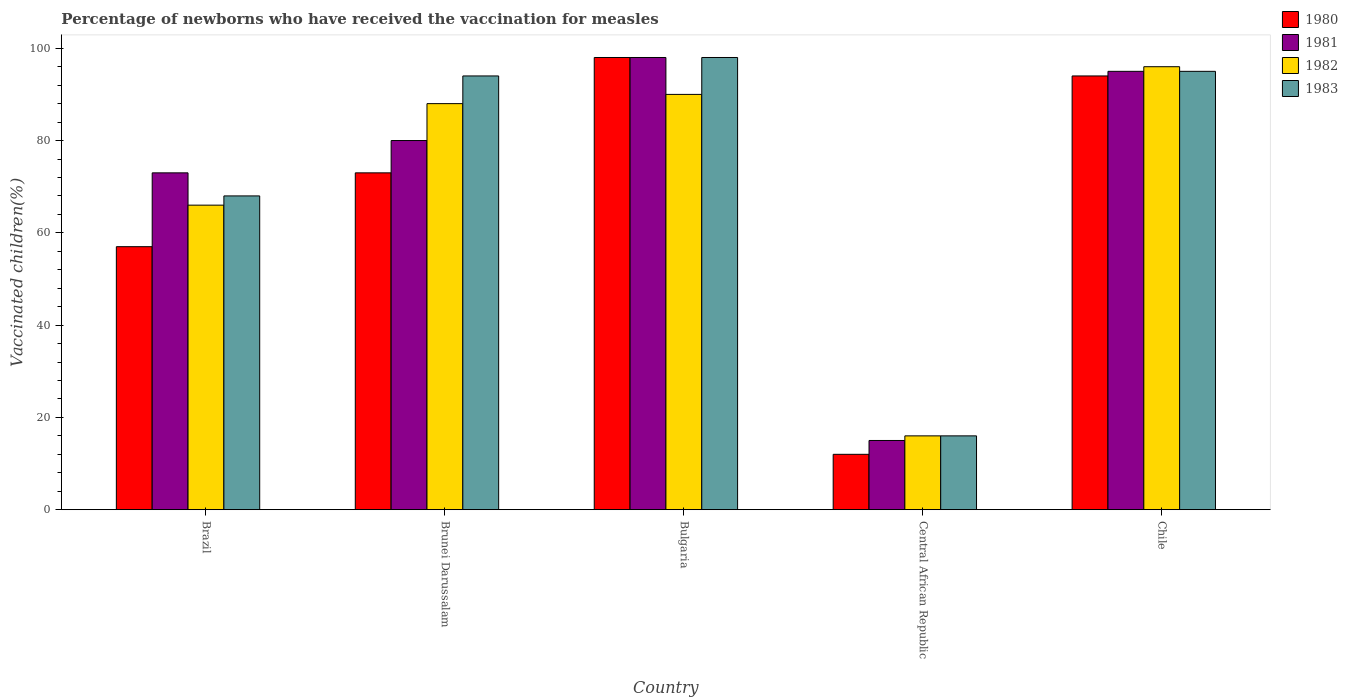How many different coloured bars are there?
Offer a very short reply. 4. Are the number of bars per tick equal to the number of legend labels?
Provide a succinct answer. Yes. Are the number of bars on each tick of the X-axis equal?
Make the answer very short. Yes. Across all countries, what is the maximum percentage of vaccinated children in 1980?
Provide a short and direct response. 98. Across all countries, what is the minimum percentage of vaccinated children in 1980?
Provide a short and direct response. 12. In which country was the percentage of vaccinated children in 1983 maximum?
Your answer should be compact. Bulgaria. In which country was the percentage of vaccinated children in 1981 minimum?
Keep it short and to the point. Central African Republic. What is the total percentage of vaccinated children in 1980 in the graph?
Make the answer very short. 334. What is the difference between the percentage of vaccinated children in 1982 in Central African Republic and the percentage of vaccinated children in 1981 in Chile?
Provide a succinct answer. -79. What is the average percentage of vaccinated children in 1982 per country?
Your response must be concise. 71.2. What is the difference between the percentage of vaccinated children of/in 1982 and percentage of vaccinated children of/in 1983 in Chile?
Give a very brief answer. 1. What is the ratio of the percentage of vaccinated children in 1981 in Brazil to that in Brunei Darussalam?
Offer a very short reply. 0.91. Is the percentage of vaccinated children in 1980 in Brazil less than that in Bulgaria?
Keep it short and to the point. Yes. Is the difference between the percentage of vaccinated children in 1982 in Brazil and Chile greater than the difference between the percentage of vaccinated children in 1983 in Brazil and Chile?
Offer a terse response. No. What is the difference between the highest and the second highest percentage of vaccinated children in 1983?
Make the answer very short. 4. What is the difference between the highest and the lowest percentage of vaccinated children in 1983?
Your answer should be compact. 82. In how many countries, is the percentage of vaccinated children in 1981 greater than the average percentage of vaccinated children in 1981 taken over all countries?
Make the answer very short. 4. Is the sum of the percentage of vaccinated children in 1982 in Central African Republic and Chile greater than the maximum percentage of vaccinated children in 1983 across all countries?
Make the answer very short. Yes. Is it the case that in every country, the sum of the percentage of vaccinated children in 1983 and percentage of vaccinated children in 1980 is greater than the sum of percentage of vaccinated children in 1981 and percentage of vaccinated children in 1982?
Keep it short and to the point. No. Is it the case that in every country, the sum of the percentage of vaccinated children in 1980 and percentage of vaccinated children in 1981 is greater than the percentage of vaccinated children in 1983?
Make the answer very short. Yes. How many countries are there in the graph?
Keep it short and to the point. 5. What is the difference between two consecutive major ticks on the Y-axis?
Offer a terse response. 20. Are the values on the major ticks of Y-axis written in scientific E-notation?
Offer a terse response. No. Where does the legend appear in the graph?
Your answer should be very brief. Top right. What is the title of the graph?
Provide a short and direct response. Percentage of newborns who have received the vaccination for measles. Does "1963" appear as one of the legend labels in the graph?
Your response must be concise. No. What is the label or title of the X-axis?
Give a very brief answer. Country. What is the label or title of the Y-axis?
Offer a very short reply. Vaccinated children(%). What is the Vaccinated children(%) in 1981 in Brazil?
Your answer should be very brief. 73. What is the Vaccinated children(%) of 1982 in Brazil?
Give a very brief answer. 66. What is the Vaccinated children(%) of 1981 in Brunei Darussalam?
Make the answer very short. 80. What is the Vaccinated children(%) in 1982 in Brunei Darussalam?
Your response must be concise. 88. What is the Vaccinated children(%) in 1983 in Brunei Darussalam?
Provide a short and direct response. 94. What is the Vaccinated children(%) in 1980 in Bulgaria?
Give a very brief answer. 98. What is the Vaccinated children(%) in 1981 in Bulgaria?
Your answer should be very brief. 98. What is the Vaccinated children(%) in 1982 in Bulgaria?
Make the answer very short. 90. What is the Vaccinated children(%) in 1980 in Central African Republic?
Provide a short and direct response. 12. What is the Vaccinated children(%) in 1981 in Central African Republic?
Keep it short and to the point. 15. What is the Vaccinated children(%) of 1982 in Central African Republic?
Make the answer very short. 16. What is the Vaccinated children(%) of 1980 in Chile?
Keep it short and to the point. 94. What is the Vaccinated children(%) of 1981 in Chile?
Your answer should be compact. 95. What is the Vaccinated children(%) of 1982 in Chile?
Ensure brevity in your answer.  96. Across all countries, what is the maximum Vaccinated children(%) of 1980?
Offer a terse response. 98. Across all countries, what is the maximum Vaccinated children(%) of 1981?
Give a very brief answer. 98. Across all countries, what is the maximum Vaccinated children(%) of 1982?
Provide a short and direct response. 96. Across all countries, what is the maximum Vaccinated children(%) of 1983?
Make the answer very short. 98. Across all countries, what is the minimum Vaccinated children(%) of 1982?
Your answer should be very brief. 16. Across all countries, what is the minimum Vaccinated children(%) of 1983?
Give a very brief answer. 16. What is the total Vaccinated children(%) of 1980 in the graph?
Your answer should be very brief. 334. What is the total Vaccinated children(%) of 1981 in the graph?
Offer a very short reply. 361. What is the total Vaccinated children(%) of 1982 in the graph?
Keep it short and to the point. 356. What is the total Vaccinated children(%) of 1983 in the graph?
Your answer should be very brief. 371. What is the difference between the Vaccinated children(%) of 1980 in Brazil and that in Brunei Darussalam?
Ensure brevity in your answer.  -16. What is the difference between the Vaccinated children(%) in 1981 in Brazil and that in Brunei Darussalam?
Keep it short and to the point. -7. What is the difference between the Vaccinated children(%) in 1982 in Brazil and that in Brunei Darussalam?
Offer a terse response. -22. What is the difference between the Vaccinated children(%) in 1980 in Brazil and that in Bulgaria?
Ensure brevity in your answer.  -41. What is the difference between the Vaccinated children(%) in 1982 in Brazil and that in Bulgaria?
Ensure brevity in your answer.  -24. What is the difference between the Vaccinated children(%) in 1980 in Brazil and that in Central African Republic?
Ensure brevity in your answer.  45. What is the difference between the Vaccinated children(%) of 1981 in Brazil and that in Central African Republic?
Your answer should be very brief. 58. What is the difference between the Vaccinated children(%) in 1982 in Brazil and that in Central African Republic?
Give a very brief answer. 50. What is the difference between the Vaccinated children(%) in 1983 in Brazil and that in Central African Republic?
Offer a very short reply. 52. What is the difference between the Vaccinated children(%) in 1980 in Brazil and that in Chile?
Keep it short and to the point. -37. What is the difference between the Vaccinated children(%) of 1981 in Brazil and that in Chile?
Ensure brevity in your answer.  -22. What is the difference between the Vaccinated children(%) in 1980 in Brunei Darussalam and that in Bulgaria?
Your answer should be very brief. -25. What is the difference between the Vaccinated children(%) of 1981 in Brunei Darussalam and that in Bulgaria?
Your answer should be compact. -18. What is the difference between the Vaccinated children(%) in 1983 in Brunei Darussalam and that in Bulgaria?
Keep it short and to the point. -4. What is the difference between the Vaccinated children(%) of 1981 in Brunei Darussalam and that in Central African Republic?
Ensure brevity in your answer.  65. What is the difference between the Vaccinated children(%) of 1980 in Brunei Darussalam and that in Chile?
Make the answer very short. -21. What is the difference between the Vaccinated children(%) of 1982 in Brunei Darussalam and that in Chile?
Offer a very short reply. -8. What is the difference between the Vaccinated children(%) in 1983 in Brunei Darussalam and that in Chile?
Keep it short and to the point. -1. What is the difference between the Vaccinated children(%) of 1982 in Bulgaria and that in Central African Republic?
Offer a very short reply. 74. What is the difference between the Vaccinated children(%) of 1982 in Bulgaria and that in Chile?
Keep it short and to the point. -6. What is the difference between the Vaccinated children(%) of 1980 in Central African Republic and that in Chile?
Your answer should be compact. -82. What is the difference between the Vaccinated children(%) in 1981 in Central African Republic and that in Chile?
Provide a short and direct response. -80. What is the difference between the Vaccinated children(%) of 1982 in Central African Republic and that in Chile?
Provide a succinct answer. -80. What is the difference between the Vaccinated children(%) of 1983 in Central African Republic and that in Chile?
Offer a terse response. -79. What is the difference between the Vaccinated children(%) of 1980 in Brazil and the Vaccinated children(%) of 1981 in Brunei Darussalam?
Make the answer very short. -23. What is the difference between the Vaccinated children(%) of 1980 in Brazil and the Vaccinated children(%) of 1982 in Brunei Darussalam?
Offer a terse response. -31. What is the difference between the Vaccinated children(%) in 1980 in Brazil and the Vaccinated children(%) in 1983 in Brunei Darussalam?
Ensure brevity in your answer.  -37. What is the difference between the Vaccinated children(%) in 1982 in Brazil and the Vaccinated children(%) in 1983 in Brunei Darussalam?
Give a very brief answer. -28. What is the difference between the Vaccinated children(%) in 1980 in Brazil and the Vaccinated children(%) in 1981 in Bulgaria?
Your answer should be compact. -41. What is the difference between the Vaccinated children(%) of 1980 in Brazil and the Vaccinated children(%) of 1982 in Bulgaria?
Give a very brief answer. -33. What is the difference between the Vaccinated children(%) of 1980 in Brazil and the Vaccinated children(%) of 1983 in Bulgaria?
Offer a very short reply. -41. What is the difference between the Vaccinated children(%) in 1981 in Brazil and the Vaccinated children(%) in 1982 in Bulgaria?
Ensure brevity in your answer.  -17. What is the difference between the Vaccinated children(%) of 1982 in Brazil and the Vaccinated children(%) of 1983 in Bulgaria?
Offer a terse response. -32. What is the difference between the Vaccinated children(%) in 1980 in Brazil and the Vaccinated children(%) in 1981 in Central African Republic?
Your answer should be compact. 42. What is the difference between the Vaccinated children(%) of 1980 in Brazil and the Vaccinated children(%) of 1982 in Central African Republic?
Offer a terse response. 41. What is the difference between the Vaccinated children(%) in 1980 in Brazil and the Vaccinated children(%) in 1983 in Central African Republic?
Your answer should be compact. 41. What is the difference between the Vaccinated children(%) in 1981 in Brazil and the Vaccinated children(%) in 1982 in Central African Republic?
Ensure brevity in your answer.  57. What is the difference between the Vaccinated children(%) in 1982 in Brazil and the Vaccinated children(%) in 1983 in Central African Republic?
Offer a very short reply. 50. What is the difference between the Vaccinated children(%) in 1980 in Brazil and the Vaccinated children(%) in 1981 in Chile?
Keep it short and to the point. -38. What is the difference between the Vaccinated children(%) in 1980 in Brazil and the Vaccinated children(%) in 1982 in Chile?
Your answer should be very brief. -39. What is the difference between the Vaccinated children(%) in 1980 in Brazil and the Vaccinated children(%) in 1983 in Chile?
Your answer should be very brief. -38. What is the difference between the Vaccinated children(%) in 1980 in Brunei Darussalam and the Vaccinated children(%) in 1983 in Bulgaria?
Offer a very short reply. -25. What is the difference between the Vaccinated children(%) in 1981 in Brunei Darussalam and the Vaccinated children(%) in 1982 in Bulgaria?
Your answer should be very brief. -10. What is the difference between the Vaccinated children(%) in 1981 in Brunei Darussalam and the Vaccinated children(%) in 1983 in Bulgaria?
Offer a terse response. -18. What is the difference between the Vaccinated children(%) in 1982 in Brunei Darussalam and the Vaccinated children(%) in 1983 in Bulgaria?
Provide a short and direct response. -10. What is the difference between the Vaccinated children(%) in 1980 in Brunei Darussalam and the Vaccinated children(%) in 1981 in Central African Republic?
Give a very brief answer. 58. What is the difference between the Vaccinated children(%) in 1980 in Brunei Darussalam and the Vaccinated children(%) in 1983 in Central African Republic?
Offer a terse response. 57. What is the difference between the Vaccinated children(%) in 1981 in Brunei Darussalam and the Vaccinated children(%) in 1982 in Central African Republic?
Give a very brief answer. 64. What is the difference between the Vaccinated children(%) in 1981 in Brunei Darussalam and the Vaccinated children(%) in 1983 in Central African Republic?
Offer a very short reply. 64. What is the difference between the Vaccinated children(%) of 1980 in Brunei Darussalam and the Vaccinated children(%) of 1981 in Chile?
Your answer should be very brief. -22. What is the difference between the Vaccinated children(%) in 1981 in Brunei Darussalam and the Vaccinated children(%) in 1982 in Chile?
Your answer should be compact. -16. What is the difference between the Vaccinated children(%) in 1980 in Bulgaria and the Vaccinated children(%) in 1983 in Central African Republic?
Your answer should be very brief. 82. What is the difference between the Vaccinated children(%) of 1981 in Bulgaria and the Vaccinated children(%) of 1983 in Central African Republic?
Your response must be concise. 82. What is the difference between the Vaccinated children(%) in 1982 in Bulgaria and the Vaccinated children(%) in 1983 in Central African Republic?
Ensure brevity in your answer.  74. What is the difference between the Vaccinated children(%) in 1980 in Bulgaria and the Vaccinated children(%) in 1981 in Chile?
Offer a terse response. 3. What is the difference between the Vaccinated children(%) in 1980 in Bulgaria and the Vaccinated children(%) in 1982 in Chile?
Make the answer very short. 2. What is the difference between the Vaccinated children(%) of 1981 in Bulgaria and the Vaccinated children(%) of 1982 in Chile?
Offer a very short reply. 2. What is the difference between the Vaccinated children(%) in 1981 in Bulgaria and the Vaccinated children(%) in 1983 in Chile?
Ensure brevity in your answer.  3. What is the difference between the Vaccinated children(%) of 1982 in Bulgaria and the Vaccinated children(%) of 1983 in Chile?
Your answer should be compact. -5. What is the difference between the Vaccinated children(%) in 1980 in Central African Republic and the Vaccinated children(%) in 1981 in Chile?
Provide a succinct answer. -83. What is the difference between the Vaccinated children(%) in 1980 in Central African Republic and the Vaccinated children(%) in 1982 in Chile?
Provide a succinct answer. -84. What is the difference between the Vaccinated children(%) of 1980 in Central African Republic and the Vaccinated children(%) of 1983 in Chile?
Offer a terse response. -83. What is the difference between the Vaccinated children(%) of 1981 in Central African Republic and the Vaccinated children(%) of 1982 in Chile?
Keep it short and to the point. -81. What is the difference between the Vaccinated children(%) of 1981 in Central African Republic and the Vaccinated children(%) of 1983 in Chile?
Your answer should be very brief. -80. What is the difference between the Vaccinated children(%) of 1982 in Central African Republic and the Vaccinated children(%) of 1983 in Chile?
Your response must be concise. -79. What is the average Vaccinated children(%) of 1980 per country?
Your answer should be very brief. 66.8. What is the average Vaccinated children(%) in 1981 per country?
Your answer should be very brief. 72.2. What is the average Vaccinated children(%) in 1982 per country?
Provide a short and direct response. 71.2. What is the average Vaccinated children(%) of 1983 per country?
Provide a succinct answer. 74.2. What is the difference between the Vaccinated children(%) in 1980 and Vaccinated children(%) in 1983 in Brazil?
Give a very brief answer. -11. What is the difference between the Vaccinated children(%) of 1981 and Vaccinated children(%) of 1982 in Brazil?
Your answer should be very brief. 7. What is the difference between the Vaccinated children(%) in 1980 and Vaccinated children(%) in 1982 in Brunei Darussalam?
Your response must be concise. -15. What is the difference between the Vaccinated children(%) of 1982 and Vaccinated children(%) of 1983 in Brunei Darussalam?
Make the answer very short. -6. What is the difference between the Vaccinated children(%) of 1980 and Vaccinated children(%) of 1982 in Bulgaria?
Your response must be concise. 8. What is the difference between the Vaccinated children(%) of 1980 and Vaccinated children(%) of 1983 in Bulgaria?
Make the answer very short. 0. What is the difference between the Vaccinated children(%) of 1981 and Vaccinated children(%) of 1983 in Bulgaria?
Provide a succinct answer. 0. What is the difference between the Vaccinated children(%) of 1982 and Vaccinated children(%) of 1983 in Bulgaria?
Your answer should be compact. -8. What is the difference between the Vaccinated children(%) in 1980 and Vaccinated children(%) in 1981 in Central African Republic?
Ensure brevity in your answer.  -3. What is the difference between the Vaccinated children(%) of 1980 and Vaccinated children(%) of 1983 in Central African Republic?
Your answer should be very brief. -4. What is the difference between the Vaccinated children(%) of 1981 and Vaccinated children(%) of 1982 in Central African Republic?
Offer a terse response. -1. What is the difference between the Vaccinated children(%) in 1981 and Vaccinated children(%) in 1983 in Central African Republic?
Make the answer very short. -1. What is the difference between the Vaccinated children(%) in 1980 and Vaccinated children(%) in 1981 in Chile?
Ensure brevity in your answer.  -1. What is the difference between the Vaccinated children(%) in 1980 and Vaccinated children(%) in 1982 in Chile?
Offer a terse response. -2. What is the difference between the Vaccinated children(%) of 1981 and Vaccinated children(%) of 1982 in Chile?
Provide a succinct answer. -1. What is the difference between the Vaccinated children(%) of 1981 and Vaccinated children(%) of 1983 in Chile?
Your answer should be compact. 0. What is the ratio of the Vaccinated children(%) of 1980 in Brazil to that in Brunei Darussalam?
Make the answer very short. 0.78. What is the ratio of the Vaccinated children(%) of 1981 in Brazil to that in Brunei Darussalam?
Provide a succinct answer. 0.91. What is the ratio of the Vaccinated children(%) in 1982 in Brazil to that in Brunei Darussalam?
Provide a succinct answer. 0.75. What is the ratio of the Vaccinated children(%) of 1983 in Brazil to that in Brunei Darussalam?
Provide a short and direct response. 0.72. What is the ratio of the Vaccinated children(%) of 1980 in Brazil to that in Bulgaria?
Offer a terse response. 0.58. What is the ratio of the Vaccinated children(%) in 1981 in Brazil to that in Bulgaria?
Offer a terse response. 0.74. What is the ratio of the Vaccinated children(%) of 1982 in Brazil to that in Bulgaria?
Your answer should be compact. 0.73. What is the ratio of the Vaccinated children(%) of 1983 in Brazil to that in Bulgaria?
Your answer should be compact. 0.69. What is the ratio of the Vaccinated children(%) of 1980 in Brazil to that in Central African Republic?
Offer a very short reply. 4.75. What is the ratio of the Vaccinated children(%) of 1981 in Brazil to that in Central African Republic?
Your response must be concise. 4.87. What is the ratio of the Vaccinated children(%) of 1982 in Brazil to that in Central African Republic?
Ensure brevity in your answer.  4.12. What is the ratio of the Vaccinated children(%) of 1983 in Brazil to that in Central African Republic?
Keep it short and to the point. 4.25. What is the ratio of the Vaccinated children(%) in 1980 in Brazil to that in Chile?
Give a very brief answer. 0.61. What is the ratio of the Vaccinated children(%) of 1981 in Brazil to that in Chile?
Your answer should be compact. 0.77. What is the ratio of the Vaccinated children(%) of 1982 in Brazil to that in Chile?
Offer a very short reply. 0.69. What is the ratio of the Vaccinated children(%) of 1983 in Brazil to that in Chile?
Make the answer very short. 0.72. What is the ratio of the Vaccinated children(%) of 1980 in Brunei Darussalam to that in Bulgaria?
Offer a very short reply. 0.74. What is the ratio of the Vaccinated children(%) in 1981 in Brunei Darussalam to that in Bulgaria?
Your response must be concise. 0.82. What is the ratio of the Vaccinated children(%) of 1982 in Brunei Darussalam to that in Bulgaria?
Give a very brief answer. 0.98. What is the ratio of the Vaccinated children(%) of 1983 in Brunei Darussalam to that in Bulgaria?
Keep it short and to the point. 0.96. What is the ratio of the Vaccinated children(%) of 1980 in Brunei Darussalam to that in Central African Republic?
Offer a terse response. 6.08. What is the ratio of the Vaccinated children(%) of 1981 in Brunei Darussalam to that in Central African Republic?
Keep it short and to the point. 5.33. What is the ratio of the Vaccinated children(%) of 1983 in Brunei Darussalam to that in Central African Republic?
Offer a very short reply. 5.88. What is the ratio of the Vaccinated children(%) of 1980 in Brunei Darussalam to that in Chile?
Provide a succinct answer. 0.78. What is the ratio of the Vaccinated children(%) of 1981 in Brunei Darussalam to that in Chile?
Offer a very short reply. 0.84. What is the ratio of the Vaccinated children(%) in 1983 in Brunei Darussalam to that in Chile?
Give a very brief answer. 0.99. What is the ratio of the Vaccinated children(%) of 1980 in Bulgaria to that in Central African Republic?
Your answer should be very brief. 8.17. What is the ratio of the Vaccinated children(%) of 1981 in Bulgaria to that in Central African Republic?
Give a very brief answer. 6.53. What is the ratio of the Vaccinated children(%) in 1982 in Bulgaria to that in Central African Republic?
Give a very brief answer. 5.62. What is the ratio of the Vaccinated children(%) of 1983 in Bulgaria to that in Central African Republic?
Offer a very short reply. 6.12. What is the ratio of the Vaccinated children(%) in 1980 in Bulgaria to that in Chile?
Offer a terse response. 1.04. What is the ratio of the Vaccinated children(%) in 1981 in Bulgaria to that in Chile?
Your response must be concise. 1.03. What is the ratio of the Vaccinated children(%) in 1983 in Bulgaria to that in Chile?
Provide a short and direct response. 1.03. What is the ratio of the Vaccinated children(%) in 1980 in Central African Republic to that in Chile?
Offer a terse response. 0.13. What is the ratio of the Vaccinated children(%) of 1981 in Central African Republic to that in Chile?
Keep it short and to the point. 0.16. What is the ratio of the Vaccinated children(%) in 1982 in Central African Republic to that in Chile?
Your response must be concise. 0.17. What is the ratio of the Vaccinated children(%) in 1983 in Central African Republic to that in Chile?
Ensure brevity in your answer.  0.17. What is the difference between the highest and the second highest Vaccinated children(%) in 1982?
Make the answer very short. 6. What is the difference between the highest and the lowest Vaccinated children(%) in 1980?
Offer a very short reply. 86. 